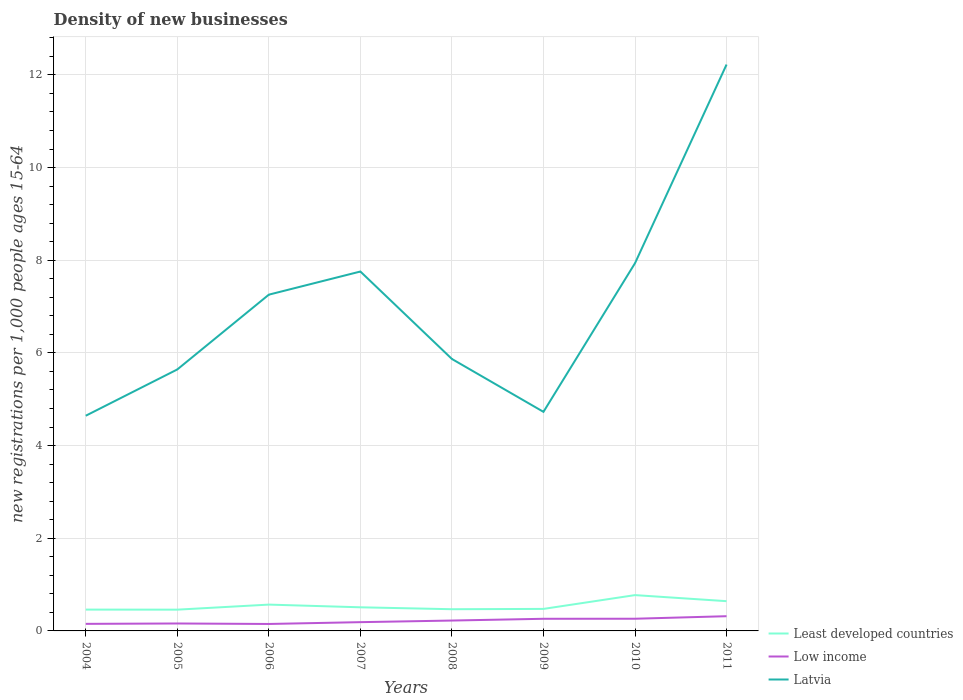Is the number of lines equal to the number of legend labels?
Your response must be concise. Yes. Across all years, what is the maximum number of new registrations in Latvia?
Ensure brevity in your answer.  4.64. What is the total number of new registrations in Least developed countries in the graph?
Provide a succinct answer. -0.11. What is the difference between the highest and the second highest number of new registrations in Latvia?
Ensure brevity in your answer.  7.58. What is the difference between the highest and the lowest number of new registrations in Low income?
Your answer should be very brief. 4. Is the number of new registrations in Least developed countries strictly greater than the number of new registrations in Low income over the years?
Your response must be concise. No. Does the graph contain grids?
Keep it short and to the point. Yes. What is the title of the graph?
Provide a short and direct response. Density of new businesses. Does "Sweden" appear as one of the legend labels in the graph?
Provide a succinct answer. No. What is the label or title of the X-axis?
Make the answer very short. Years. What is the label or title of the Y-axis?
Provide a succinct answer. New registrations per 1,0 people ages 15-64. What is the new registrations per 1,000 people ages 15-64 of Least developed countries in 2004?
Keep it short and to the point. 0.46. What is the new registrations per 1,000 people ages 15-64 in Low income in 2004?
Your answer should be compact. 0.15. What is the new registrations per 1,000 people ages 15-64 in Latvia in 2004?
Offer a terse response. 4.64. What is the new registrations per 1,000 people ages 15-64 of Least developed countries in 2005?
Your answer should be compact. 0.46. What is the new registrations per 1,000 people ages 15-64 in Low income in 2005?
Provide a succinct answer. 0.16. What is the new registrations per 1,000 people ages 15-64 in Latvia in 2005?
Ensure brevity in your answer.  5.64. What is the new registrations per 1,000 people ages 15-64 in Least developed countries in 2006?
Offer a very short reply. 0.57. What is the new registrations per 1,000 people ages 15-64 of Low income in 2006?
Give a very brief answer. 0.15. What is the new registrations per 1,000 people ages 15-64 of Latvia in 2006?
Provide a short and direct response. 7.26. What is the new registrations per 1,000 people ages 15-64 of Least developed countries in 2007?
Make the answer very short. 0.51. What is the new registrations per 1,000 people ages 15-64 of Low income in 2007?
Offer a terse response. 0.19. What is the new registrations per 1,000 people ages 15-64 in Latvia in 2007?
Give a very brief answer. 7.76. What is the new registrations per 1,000 people ages 15-64 of Least developed countries in 2008?
Give a very brief answer. 0.47. What is the new registrations per 1,000 people ages 15-64 in Low income in 2008?
Provide a succinct answer. 0.22. What is the new registrations per 1,000 people ages 15-64 of Latvia in 2008?
Provide a succinct answer. 5.87. What is the new registrations per 1,000 people ages 15-64 in Least developed countries in 2009?
Keep it short and to the point. 0.48. What is the new registrations per 1,000 people ages 15-64 in Low income in 2009?
Keep it short and to the point. 0.26. What is the new registrations per 1,000 people ages 15-64 in Latvia in 2009?
Give a very brief answer. 4.73. What is the new registrations per 1,000 people ages 15-64 of Least developed countries in 2010?
Your response must be concise. 0.77. What is the new registrations per 1,000 people ages 15-64 of Low income in 2010?
Your answer should be very brief. 0.26. What is the new registrations per 1,000 people ages 15-64 of Latvia in 2010?
Provide a succinct answer. 7.94. What is the new registrations per 1,000 people ages 15-64 in Least developed countries in 2011?
Your response must be concise. 0.64. What is the new registrations per 1,000 people ages 15-64 of Low income in 2011?
Give a very brief answer. 0.32. What is the new registrations per 1,000 people ages 15-64 of Latvia in 2011?
Keep it short and to the point. 12.22. Across all years, what is the maximum new registrations per 1,000 people ages 15-64 of Least developed countries?
Provide a succinct answer. 0.77. Across all years, what is the maximum new registrations per 1,000 people ages 15-64 in Low income?
Your answer should be very brief. 0.32. Across all years, what is the maximum new registrations per 1,000 people ages 15-64 in Latvia?
Provide a short and direct response. 12.22. Across all years, what is the minimum new registrations per 1,000 people ages 15-64 of Least developed countries?
Ensure brevity in your answer.  0.46. Across all years, what is the minimum new registrations per 1,000 people ages 15-64 in Low income?
Provide a short and direct response. 0.15. Across all years, what is the minimum new registrations per 1,000 people ages 15-64 in Latvia?
Your response must be concise. 4.64. What is the total new registrations per 1,000 people ages 15-64 of Least developed countries in the graph?
Your answer should be very brief. 4.36. What is the total new registrations per 1,000 people ages 15-64 in Low income in the graph?
Your response must be concise. 1.72. What is the total new registrations per 1,000 people ages 15-64 of Latvia in the graph?
Offer a terse response. 56.06. What is the difference between the new registrations per 1,000 people ages 15-64 of Least developed countries in 2004 and that in 2005?
Offer a terse response. 0. What is the difference between the new registrations per 1,000 people ages 15-64 in Low income in 2004 and that in 2005?
Your answer should be very brief. -0.01. What is the difference between the new registrations per 1,000 people ages 15-64 of Latvia in 2004 and that in 2005?
Give a very brief answer. -1. What is the difference between the new registrations per 1,000 people ages 15-64 of Least developed countries in 2004 and that in 2006?
Give a very brief answer. -0.11. What is the difference between the new registrations per 1,000 people ages 15-64 of Low income in 2004 and that in 2006?
Your answer should be very brief. 0. What is the difference between the new registrations per 1,000 people ages 15-64 in Latvia in 2004 and that in 2006?
Your answer should be compact. -2.61. What is the difference between the new registrations per 1,000 people ages 15-64 of Least developed countries in 2004 and that in 2007?
Your response must be concise. -0.05. What is the difference between the new registrations per 1,000 people ages 15-64 of Low income in 2004 and that in 2007?
Provide a short and direct response. -0.04. What is the difference between the new registrations per 1,000 people ages 15-64 in Latvia in 2004 and that in 2007?
Your answer should be very brief. -3.11. What is the difference between the new registrations per 1,000 people ages 15-64 in Least developed countries in 2004 and that in 2008?
Your answer should be compact. -0.01. What is the difference between the new registrations per 1,000 people ages 15-64 in Low income in 2004 and that in 2008?
Offer a very short reply. -0.07. What is the difference between the new registrations per 1,000 people ages 15-64 of Latvia in 2004 and that in 2008?
Offer a terse response. -1.23. What is the difference between the new registrations per 1,000 people ages 15-64 in Least developed countries in 2004 and that in 2009?
Give a very brief answer. -0.01. What is the difference between the new registrations per 1,000 people ages 15-64 in Low income in 2004 and that in 2009?
Ensure brevity in your answer.  -0.11. What is the difference between the new registrations per 1,000 people ages 15-64 of Latvia in 2004 and that in 2009?
Offer a terse response. -0.08. What is the difference between the new registrations per 1,000 people ages 15-64 of Least developed countries in 2004 and that in 2010?
Your answer should be compact. -0.31. What is the difference between the new registrations per 1,000 people ages 15-64 of Low income in 2004 and that in 2010?
Provide a succinct answer. -0.11. What is the difference between the new registrations per 1,000 people ages 15-64 in Latvia in 2004 and that in 2010?
Offer a very short reply. -3.29. What is the difference between the new registrations per 1,000 people ages 15-64 of Least developed countries in 2004 and that in 2011?
Your response must be concise. -0.18. What is the difference between the new registrations per 1,000 people ages 15-64 in Low income in 2004 and that in 2011?
Make the answer very short. -0.17. What is the difference between the new registrations per 1,000 people ages 15-64 of Latvia in 2004 and that in 2011?
Offer a terse response. -7.58. What is the difference between the new registrations per 1,000 people ages 15-64 of Least developed countries in 2005 and that in 2006?
Keep it short and to the point. -0.11. What is the difference between the new registrations per 1,000 people ages 15-64 in Low income in 2005 and that in 2006?
Offer a very short reply. 0.01. What is the difference between the new registrations per 1,000 people ages 15-64 in Latvia in 2005 and that in 2006?
Provide a short and direct response. -1.61. What is the difference between the new registrations per 1,000 people ages 15-64 in Least developed countries in 2005 and that in 2007?
Your answer should be very brief. -0.05. What is the difference between the new registrations per 1,000 people ages 15-64 of Low income in 2005 and that in 2007?
Your answer should be compact. -0.03. What is the difference between the new registrations per 1,000 people ages 15-64 of Latvia in 2005 and that in 2007?
Offer a terse response. -2.11. What is the difference between the new registrations per 1,000 people ages 15-64 in Least developed countries in 2005 and that in 2008?
Offer a terse response. -0.01. What is the difference between the new registrations per 1,000 people ages 15-64 of Low income in 2005 and that in 2008?
Provide a succinct answer. -0.06. What is the difference between the new registrations per 1,000 people ages 15-64 of Latvia in 2005 and that in 2008?
Make the answer very short. -0.23. What is the difference between the new registrations per 1,000 people ages 15-64 of Least developed countries in 2005 and that in 2009?
Ensure brevity in your answer.  -0.02. What is the difference between the new registrations per 1,000 people ages 15-64 in Low income in 2005 and that in 2009?
Ensure brevity in your answer.  -0.1. What is the difference between the new registrations per 1,000 people ages 15-64 of Latvia in 2005 and that in 2009?
Offer a very short reply. 0.92. What is the difference between the new registrations per 1,000 people ages 15-64 of Least developed countries in 2005 and that in 2010?
Provide a succinct answer. -0.31. What is the difference between the new registrations per 1,000 people ages 15-64 in Low income in 2005 and that in 2010?
Your answer should be compact. -0.1. What is the difference between the new registrations per 1,000 people ages 15-64 in Latvia in 2005 and that in 2010?
Provide a succinct answer. -2.29. What is the difference between the new registrations per 1,000 people ages 15-64 of Least developed countries in 2005 and that in 2011?
Provide a short and direct response. -0.18. What is the difference between the new registrations per 1,000 people ages 15-64 of Low income in 2005 and that in 2011?
Your response must be concise. -0.16. What is the difference between the new registrations per 1,000 people ages 15-64 of Latvia in 2005 and that in 2011?
Provide a short and direct response. -6.58. What is the difference between the new registrations per 1,000 people ages 15-64 in Least developed countries in 2006 and that in 2007?
Provide a short and direct response. 0.06. What is the difference between the new registrations per 1,000 people ages 15-64 of Low income in 2006 and that in 2007?
Provide a short and direct response. -0.04. What is the difference between the new registrations per 1,000 people ages 15-64 of Latvia in 2006 and that in 2007?
Offer a terse response. -0.5. What is the difference between the new registrations per 1,000 people ages 15-64 in Least developed countries in 2006 and that in 2008?
Offer a very short reply. 0.1. What is the difference between the new registrations per 1,000 people ages 15-64 in Low income in 2006 and that in 2008?
Ensure brevity in your answer.  -0.07. What is the difference between the new registrations per 1,000 people ages 15-64 in Latvia in 2006 and that in 2008?
Your response must be concise. 1.39. What is the difference between the new registrations per 1,000 people ages 15-64 of Least developed countries in 2006 and that in 2009?
Offer a terse response. 0.09. What is the difference between the new registrations per 1,000 people ages 15-64 of Low income in 2006 and that in 2009?
Your response must be concise. -0.11. What is the difference between the new registrations per 1,000 people ages 15-64 in Latvia in 2006 and that in 2009?
Give a very brief answer. 2.53. What is the difference between the new registrations per 1,000 people ages 15-64 of Least developed countries in 2006 and that in 2010?
Ensure brevity in your answer.  -0.2. What is the difference between the new registrations per 1,000 people ages 15-64 of Low income in 2006 and that in 2010?
Provide a short and direct response. -0.11. What is the difference between the new registrations per 1,000 people ages 15-64 of Latvia in 2006 and that in 2010?
Offer a very short reply. -0.68. What is the difference between the new registrations per 1,000 people ages 15-64 in Least developed countries in 2006 and that in 2011?
Provide a succinct answer. -0.07. What is the difference between the new registrations per 1,000 people ages 15-64 of Low income in 2006 and that in 2011?
Provide a short and direct response. -0.17. What is the difference between the new registrations per 1,000 people ages 15-64 of Latvia in 2006 and that in 2011?
Provide a succinct answer. -4.97. What is the difference between the new registrations per 1,000 people ages 15-64 of Least developed countries in 2007 and that in 2008?
Your answer should be compact. 0.04. What is the difference between the new registrations per 1,000 people ages 15-64 of Low income in 2007 and that in 2008?
Your answer should be compact. -0.03. What is the difference between the new registrations per 1,000 people ages 15-64 of Latvia in 2007 and that in 2008?
Your answer should be very brief. 1.89. What is the difference between the new registrations per 1,000 people ages 15-64 of Least developed countries in 2007 and that in 2009?
Provide a short and direct response. 0.03. What is the difference between the new registrations per 1,000 people ages 15-64 in Low income in 2007 and that in 2009?
Give a very brief answer. -0.07. What is the difference between the new registrations per 1,000 people ages 15-64 in Latvia in 2007 and that in 2009?
Ensure brevity in your answer.  3.03. What is the difference between the new registrations per 1,000 people ages 15-64 of Least developed countries in 2007 and that in 2010?
Provide a succinct answer. -0.26. What is the difference between the new registrations per 1,000 people ages 15-64 of Low income in 2007 and that in 2010?
Your answer should be very brief. -0.07. What is the difference between the new registrations per 1,000 people ages 15-64 of Latvia in 2007 and that in 2010?
Your response must be concise. -0.18. What is the difference between the new registrations per 1,000 people ages 15-64 in Least developed countries in 2007 and that in 2011?
Offer a terse response. -0.13. What is the difference between the new registrations per 1,000 people ages 15-64 of Low income in 2007 and that in 2011?
Keep it short and to the point. -0.13. What is the difference between the new registrations per 1,000 people ages 15-64 of Latvia in 2007 and that in 2011?
Your answer should be very brief. -4.47. What is the difference between the new registrations per 1,000 people ages 15-64 of Least developed countries in 2008 and that in 2009?
Keep it short and to the point. -0.01. What is the difference between the new registrations per 1,000 people ages 15-64 of Low income in 2008 and that in 2009?
Your answer should be very brief. -0.04. What is the difference between the new registrations per 1,000 people ages 15-64 in Latvia in 2008 and that in 2009?
Your response must be concise. 1.14. What is the difference between the new registrations per 1,000 people ages 15-64 in Least developed countries in 2008 and that in 2010?
Offer a terse response. -0.3. What is the difference between the new registrations per 1,000 people ages 15-64 of Low income in 2008 and that in 2010?
Your answer should be compact. -0.04. What is the difference between the new registrations per 1,000 people ages 15-64 in Latvia in 2008 and that in 2010?
Offer a terse response. -2.07. What is the difference between the new registrations per 1,000 people ages 15-64 in Least developed countries in 2008 and that in 2011?
Provide a succinct answer. -0.17. What is the difference between the new registrations per 1,000 people ages 15-64 in Low income in 2008 and that in 2011?
Make the answer very short. -0.09. What is the difference between the new registrations per 1,000 people ages 15-64 of Latvia in 2008 and that in 2011?
Your answer should be compact. -6.35. What is the difference between the new registrations per 1,000 people ages 15-64 in Least developed countries in 2009 and that in 2010?
Your answer should be compact. -0.3. What is the difference between the new registrations per 1,000 people ages 15-64 in Low income in 2009 and that in 2010?
Your answer should be compact. -0. What is the difference between the new registrations per 1,000 people ages 15-64 in Latvia in 2009 and that in 2010?
Keep it short and to the point. -3.21. What is the difference between the new registrations per 1,000 people ages 15-64 of Least developed countries in 2009 and that in 2011?
Your answer should be very brief. -0.17. What is the difference between the new registrations per 1,000 people ages 15-64 in Low income in 2009 and that in 2011?
Offer a very short reply. -0.06. What is the difference between the new registrations per 1,000 people ages 15-64 of Latvia in 2009 and that in 2011?
Offer a terse response. -7.5. What is the difference between the new registrations per 1,000 people ages 15-64 in Least developed countries in 2010 and that in 2011?
Ensure brevity in your answer.  0.13. What is the difference between the new registrations per 1,000 people ages 15-64 in Low income in 2010 and that in 2011?
Provide a short and direct response. -0.05. What is the difference between the new registrations per 1,000 people ages 15-64 of Latvia in 2010 and that in 2011?
Offer a very short reply. -4.29. What is the difference between the new registrations per 1,000 people ages 15-64 of Least developed countries in 2004 and the new registrations per 1,000 people ages 15-64 of Low income in 2005?
Your answer should be compact. 0.3. What is the difference between the new registrations per 1,000 people ages 15-64 in Least developed countries in 2004 and the new registrations per 1,000 people ages 15-64 in Latvia in 2005?
Provide a short and direct response. -5.18. What is the difference between the new registrations per 1,000 people ages 15-64 of Low income in 2004 and the new registrations per 1,000 people ages 15-64 of Latvia in 2005?
Ensure brevity in your answer.  -5.49. What is the difference between the new registrations per 1,000 people ages 15-64 of Least developed countries in 2004 and the new registrations per 1,000 people ages 15-64 of Low income in 2006?
Make the answer very short. 0.31. What is the difference between the new registrations per 1,000 people ages 15-64 in Least developed countries in 2004 and the new registrations per 1,000 people ages 15-64 in Latvia in 2006?
Your answer should be compact. -6.8. What is the difference between the new registrations per 1,000 people ages 15-64 in Low income in 2004 and the new registrations per 1,000 people ages 15-64 in Latvia in 2006?
Your answer should be very brief. -7.11. What is the difference between the new registrations per 1,000 people ages 15-64 of Least developed countries in 2004 and the new registrations per 1,000 people ages 15-64 of Low income in 2007?
Offer a very short reply. 0.27. What is the difference between the new registrations per 1,000 people ages 15-64 in Least developed countries in 2004 and the new registrations per 1,000 people ages 15-64 in Latvia in 2007?
Offer a very short reply. -7.3. What is the difference between the new registrations per 1,000 people ages 15-64 of Low income in 2004 and the new registrations per 1,000 people ages 15-64 of Latvia in 2007?
Make the answer very short. -7.6. What is the difference between the new registrations per 1,000 people ages 15-64 in Least developed countries in 2004 and the new registrations per 1,000 people ages 15-64 in Low income in 2008?
Provide a short and direct response. 0.24. What is the difference between the new registrations per 1,000 people ages 15-64 of Least developed countries in 2004 and the new registrations per 1,000 people ages 15-64 of Latvia in 2008?
Make the answer very short. -5.41. What is the difference between the new registrations per 1,000 people ages 15-64 of Low income in 2004 and the new registrations per 1,000 people ages 15-64 of Latvia in 2008?
Make the answer very short. -5.72. What is the difference between the new registrations per 1,000 people ages 15-64 in Least developed countries in 2004 and the new registrations per 1,000 people ages 15-64 in Low income in 2009?
Offer a very short reply. 0.2. What is the difference between the new registrations per 1,000 people ages 15-64 in Least developed countries in 2004 and the new registrations per 1,000 people ages 15-64 in Latvia in 2009?
Your answer should be very brief. -4.27. What is the difference between the new registrations per 1,000 people ages 15-64 in Low income in 2004 and the new registrations per 1,000 people ages 15-64 in Latvia in 2009?
Ensure brevity in your answer.  -4.58. What is the difference between the new registrations per 1,000 people ages 15-64 of Least developed countries in 2004 and the new registrations per 1,000 people ages 15-64 of Low income in 2010?
Keep it short and to the point. 0.2. What is the difference between the new registrations per 1,000 people ages 15-64 of Least developed countries in 2004 and the new registrations per 1,000 people ages 15-64 of Latvia in 2010?
Provide a succinct answer. -7.48. What is the difference between the new registrations per 1,000 people ages 15-64 in Low income in 2004 and the new registrations per 1,000 people ages 15-64 in Latvia in 2010?
Your response must be concise. -7.78. What is the difference between the new registrations per 1,000 people ages 15-64 of Least developed countries in 2004 and the new registrations per 1,000 people ages 15-64 of Low income in 2011?
Offer a very short reply. 0.14. What is the difference between the new registrations per 1,000 people ages 15-64 of Least developed countries in 2004 and the new registrations per 1,000 people ages 15-64 of Latvia in 2011?
Ensure brevity in your answer.  -11.76. What is the difference between the new registrations per 1,000 people ages 15-64 in Low income in 2004 and the new registrations per 1,000 people ages 15-64 in Latvia in 2011?
Provide a succinct answer. -12.07. What is the difference between the new registrations per 1,000 people ages 15-64 in Least developed countries in 2005 and the new registrations per 1,000 people ages 15-64 in Low income in 2006?
Ensure brevity in your answer.  0.31. What is the difference between the new registrations per 1,000 people ages 15-64 of Least developed countries in 2005 and the new registrations per 1,000 people ages 15-64 of Latvia in 2006?
Your answer should be very brief. -6.8. What is the difference between the new registrations per 1,000 people ages 15-64 in Low income in 2005 and the new registrations per 1,000 people ages 15-64 in Latvia in 2006?
Offer a very short reply. -7.1. What is the difference between the new registrations per 1,000 people ages 15-64 of Least developed countries in 2005 and the new registrations per 1,000 people ages 15-64 of Low income in 2007?
Ensure brevity in your answer.  0.27. What is the difference between the new registrations per 1,000 people ages 15-64 in Least developed countries in 2005 and the new registrations per 1,000 people ages 15-64 in Latvia in 2007?
Your answer should be very brief. -7.3. What is the difference between the new registrations per 1,000 people ages 15-64 in Low income in 2005 and the new registrations per 1,000 people ages 15-64 in Latvia in 2007?
Ensure brevity in your answer.  -7.6. What is the difference between the new registrations per 1,000 people ages 15-64 of Least developed countries in 2005 and the new registrations per 1,000 people ages 15-64 of Low income in 2008?
Provide a short and direct response. 0.23. What is the difference between the new registrations per 1,000 people ages 15-64 of Least developed countries in 2005 and the new registrations per 1,000 people ages 15-64 of Latvia in 2008?
Provide a succinct answer. -5.41. What is the difference between the new registrations per 1,000 people ages 15-64 in Low income in 2005 and the new registrations per 1,000 people ages 15-64 in Latvia in 2008?
Provide a succinct answer. -5.71. What is the difference between the new registrations per 1,000 people ages 15-64 in Least developed countries in 2005 and the new registrations per 1,000 people ages 15-64 in Low income in 2009?
Ensure brevity in your answer.  0.2. What is the difference between the new registrations per 1,000 people ages 15-64 in Least developed countries in 2005 and the new registrations per 1,000 people ages 15-64 in Latvia in 2009?
Keep it short and to the point. -4.27. What is the difference between the new registrations per 1,000 people ages 15-64 in Low income in 2005 and the new registrations per 1,000 people ages 15-64 in Latvia in 2009?
Your response must be concise. -4.57. What is the difference between the new registrations per 1,000 people ages 15-64 of Least developed countries in 2005 and the new registrations per 1,000 people ages 15-64 of Low income in 2010?
Offer a very short reply. 0.2. What is the difference between the new registrations per 1,000 people ages 15-64 of Least developed countries in 2005 and the new registrations per 1,000 people ages 15-64 of Latvia in 2010?
Keep it short and to the point. -7.48. What is the difference between the new registrations per 1,000 people ages 15-64 in Low income in 2005 and the new registrations per 1,000 people ages 15-64 in Latvia in 2010?
Keep it short and to the point. -7.78. What is the difference between the new registrations per 1,000 people ages 15-64 of Least developed countries in 2005 and the new registrations per 1,000 people ages 15-64 of Low income in 2011?
Offer a very short reply. 0.14. What is the difference between the new registrations per 1,000 people ages 15-64 in Least developed countries in 2005 and the new registrations per 1,000 people ages 15-64 in Latvia in 2011?
Your response must be concise. -11.77. What is the difference between the new registrations per 1,000 people ages 15-64 of Low income in 2005 and the new registrations per 1,000 people ages 15-64 of Latvia in 2011?
Offer a very short reply. -12.06. What is the difference between the new registrations per 1,000 people ages 15-64 of Least developed countries in 2006 and the new registrations per 1,000 people ages 15-64 of Low income in 2007?
Keep it short and to the point. 0.38. What is the difference between the new registrations per 1,000 people ages 15-64 in Least developed countries in 2006 and the new registrations per 1,000 people ages 15-64 in Latvia in 2007?
Make the answer very short. -7.19. What is the difference between the new registrations per 1,000 people ages 15-64 in Low income in 2006 and the new registrations per 1,000 people ages 15-64 in Latvia in 2007?
Your answer should be very brief. -7.61. What is the difference between the new registrations per 1,000 people ages 15-64 of Least developed countries in 2006 and the new registrations per 1,000 people ages 15-64 of Low income in 2008?
Your response must be concise. 0.34. What is the difference between the new registrations per 1,000 people ages 15-64 in Least developed countries in 2006 and the new registrations per 1,000 people ages 15-64 in Latvia in 2008?
Offer a very short reply. -5.3. What is the difference between the new registrations per 1,000 people ages 15-64 in Low income in 2006 and the new registrations per 1,000 people ages 15-64 in Latvia in 2008?
Provide a short and direct response. -5.72. What is the difference between the new registrations per 1,000 people ages 15-64 in Least developed countries in 2006 and the new registrations per 1,000 people ages 15-64 in Low income in 2009?
Offer a very short reply. 0.31. What is the difference between the new registrations per 1,000 people ages 15-64 in Least developed countries in 2006 and the new registrations per 1,000 people ages 15-64 in Latvia in 2009?
Offer a terse response. -4.16. What is the difference between the new registrations per 1,000 people ages 15-64 of Low income in 2006 and the new registrations per 1,000 people ages 15-64 of Latvia in 2009?
Offer a terse response. -4.58. What is the difference between the new registrations per 1,000 people ages 15-64 of Least developed countries in 2006 and the new registrations per 1,000 people ages 15-64 of Low income in 2010?
Give a very brief answer. 0.31. What is the difference between the new registrations per 1,000 people ages 15-64 in Least developed countries in 2006 and the new registrations per 1,000 people ages 15-64 in Latvia in 2010?
Give a very brief answer. -7.37. What is the difference between the new registrations per 1,000 people ages 15-64 in Low income in 2006 and the new registrations per 1,000 people ages 15-64 in Latvia in 2010?
Provide a short and direct response. -7.79. What is the difference between the new registrations per 1,000 people ages 15-64 in Least developed countries in 2006 and the new registrations per 1,000 people ages 15-64 in Low income in 2011?
Ensure brevity in your answer.  0.25. What is the difference between the new registrations per 1,000 people ages 15-64 of Least developed countries in 2006 and the new registrations per 1,000 people ages 15-64 of Latvia in 2011?
Keep it short and to the point. -11.66. What is the difference between the new registrations per 1,000 people ages 15-64 of Low income in 2006 and the new registrations per 1,000 people ages 15-64 of Latvia in 2011?
Ensure brevity in your answer.  -12.07. What is the difference between the new registrations per 1,000 people ages 15-64 of Least developed countries in 2007 and the new registrations per 1,000 people ages 15-64 of Low income in 2008?
Your answer should be very brief. 0.29. What is the difference between the new registrations per 1,000 people ages 15-64 in Least developed countries in 2007 and the new registrations per 1,000 people ages 15-64 in Latvia in 2008?
Ensure brevity in your answer.  -5.36. What is the difference between the new registrations per 1,000 people ages 15-64 in Low income in 2007 and the new registrations per 1,000 people ages 15-64 in Latvia in 2008?
Your answer should be very brief. -5.68. What is the difference between the new registrations per 1,000 people ages 15-64 of Least developed countries in 2007 and the new registrations per 1,000 people ages 15-64 of Low income in 2009?
Offer a terse response. 0.25. What is the difference between the new registrations per 1,000 people ages 15-64 in Least developed countries in 2007 and the new registrations per 1,000 people ages 15-64 in Latvia in 2009?
Offer a very short reply. -4.22. What is the difference between the new registrations per 1,000 people ages 15-64 in Low income in 2007 and the new registrations per 1,000 people ages 15-64 in Latvia in 2009?
Give a very brief answer. -4.54. What is the difference between the new registrations per 1,000 people ages 15-64 of Least developed countries in 2007 and the new registrations per 1,000 people ages 15-64 of Low income in 2010?
Your answer should be compact. 0.25. What is the difference between the new registrations per 1,000 people ages 15-64 in Least developed countries in 2007 and the new registrations per 1,000 people ages 15-64 in Latvia in 2010?
Provide a short and direct response. -7.43. What is the difference between the new registrations per 1,000 people ages 15-64 in Low income in 2007 and the new registrations per 1,000 people ages 15-64 in Latvia in 2010?
Your answer should be very brief. -7.75. What is the difference between the new registrations per 1,000 people ages 15-64 in Least developed countries in 2007 and the new registrations per 1,000 people ages 15-64 in Low income in 2011?
Your response must be concise. 0.19. What is the difference between the new registrations per 1,000 people ages 15-64 in Least developed countries in 2007 and the new registrations per 1,000 people ages 15-64 in Latvia in 2011?
Provide a succinct answer. -11.71. What is the difference between the new registrations per 1,000 people ages 15-64 in Low income in 2007 and the new registrations per 1,000 people ages 15-64 in Latvia in 2011?
Offer a very short reply. -12.03. What is the difference between the new registrations per 1,000 people ages 15-64 of Least developed countries in 2008 and the new registrations per 1,000 people ages 15-64 of Low income in 2009?
Offer a very short reply. 0.21. What is the difference between the new registrations per 1,000 people ages 15-64 in Least developed countries in 2008 and the new registrations per 1,000 people ages 15-64 in Latvia in 2009?
Provide a succinct answer. -4.26. What is the difference between the new registrations per 1,000 people ages 15-64 in Low income in 2008 and the new registrations per 1,000 people ages 15-64 in Latvia in 2009?
Ensure brevity in your answer.  -4.5. What is the difference between the new registrations per 1,000 people ages 15-64 of Least developed countries in 2008 and the new registrations per 1,000 people ages 15-64 of Low income in 2010?
Make the answer very short. 0.21. What is the difference between the new registrations per 1,000 people ages 15-64 in Least developed countries in 2008 and the new registrations per 1,000 people ages 15-64 in Latvia in 2010?
Provide a succinct answer. -7.47. What is the difference between the new registrations per 1,000 people ages 15-64 in Low income in 2008 and the new registrations per 1,000 people ages 15-64 in Latvia in 2010?
Offer a terse response. -7.71. What is the difference between the new registrations per 1,000 people ages 15-64 of Least developed countries in 2008 and the new registrations per 1,000 people ages 15-64 of Low income in 2011?
Provide a short and direct response. 0.15. What is the difference between the new registrations per 1,000 people ages 15-64 in Least developed countries in 2008 and the new registrations per 1,000 people ages 15-64 in Latvia in 2011?
Your answer should be compact. -11.76. What is the difference between the new registrations per 1,000 people ages 15-64 in Low income in 2008 and the new registrations per 1,000 people ages 15-64 in Latvia in 2011?
Offer a terse response. -12. What is the difference between the new registrations per 1,000 people ages 15-64 in Least developed countries in 2009 and the new registrations per 1,000 people ages 15-64 in Low income in 2010?
Your response must be concise. 0.21. What is the difference between the new registrations per 1,000 people ages 15-64 in Least developed countries in 2009 and the new registrations per 1,000 people ages 15-64 in Latvia in 2010?
Offer a very short reply. -7.46. What is the difference between the new registrations per 1,000 people ages 15-64 in Low income in 2009 and the new registrations per 1,000 people ages 15-64 in Latvia in 2010?
Offer a terse response. -7.67. What is the difference between the new registrations per 1,000 people ages 15-64 in Least developed countries in 2009 and the new registrations per 1,000 people ages 15-64 in Low income in 2011?
Give a very brief answer. 0.16. What is the difference between the new registrations per 1,000 people ages 15-64 in Least developed countries in 2009 and the new registrations per 1,000 people ages 15-64 in Latvia in 2011?
Offer a terse response. -11.75. What is the difference between the new registrations per 1,000 people ages 15-64 of Low income in 2009 and the new registrations per 1,000 people ages 15-64 of Latvia in 2011?
Give a very brief answer. -11.96. What is the difference between the new registrations per 1,000 people ages 15-64 in Least developed countries in 2010 and the new registrations per 1,000 people ages 15-64 in Low income in 2011?
Keep it short and to the point. 0.46. What is the difference between the new registrations per 1,000 people ages 15-64 in Least developed countries in 2010 and the new registrations per 1,000 people ages 15-64 in Latvia in 2011?
Make the answer very short. -11.45. What is the difference between the new registrations per 1,000 people ages 15-64 in Low income in 2010 and the new registrations per 1,000 people ages 15-64 in Latvia in 2011?
Give a very brief answer. -11.96. What is the average new registrations per 1,000 people ages 15-64 of Least developed countries per year?
Offer a terse response. 0.54. What is the average new registrations per 1,000 people ages 15-64 in Low income per year?
Your answer should be compact. 0.21. What is the average new registrations per 1,000 people ages 15-64 in Latvia per year?
Your answer should be very brief. 7.01. In the year 2004, what is the difference between the new registrations per 1,000 people ages 15-64 in Least developed countries and new registrations per 1,000 people ages 15-64 in Low income?
Give a very brief answer. 0.31. In the year 2004, what is the difference between the new registrations per 1,000 people ages 15-64 in Least developed countries and new registrations per 1,000 people ages 15-64 in Latvia?
Give a very brief answer. -4.18. In the year 2004, what is the difference between the new registrations per 1,000 people ages 15-64 of Low income and new registrations per 1,000 people ages 15-64 of Latvia?
Offer a terse response. -4.49. In the year 2005, what is the difference between the new registrations per 1,000 people ages 15-64 of Least developed countries and new registrations per 1,000 people ages 15-64 of Low income?
Offer a terse response. 0.3. In the year 2005, what is the difference between the new registrations per 1,000 people ages 15-64 of Least developed countries and new registrations per 1,000 people ages 15-64 of Latvia?
Give a very brief answer. -5.18. In the year 2005, what is the difference between the new registrations per 1,000 people ages 15-64 in Low income and new registrations per 1,000 people ages 15-64 in Latvia?
Your response must be concise. -5.48. In the year 2006, what is the difference between the new registrations per 1,000 people ages 15-64 in Least developed countries and new registrations per 1,000 people ages 15-64 in Low income?
Make the answer very short. 0.42. In the year 2006, what is the difference between the new registrations per 1,000 people ages 15-64 in Least developed countries and new registrations per 1,000 people ages 15-64 in Latvia?
Your answer should be compact. -6.69. In the year 2006, what is the difference between the new registrations per 1,000 people ages 15-64 in Low income and new registrations per 1,000 people ages 15-64 in Latvia?
Offer a very short reply. -7.11. In the year 2007, what is the difference between the new registrations per 1,000 people ages 15-64 in Least developed countries and new registrations per 1,000 people ages 15-64 in Low income?
Offer a very short reply. 0.32. In the year 2007, what is the difference between the new registrations per 1,000 people ages 15-64 of Least developed countries and new registrations per 1,000 people ages 15-64 of Latvia?
Your response must be concise. -7.25. In the year 2007, what is the difference between the new registrations per 1,000 people ages 15-64 in Low income and new registrations per 1,000 people ages 15-64 in Latvia?
Offer a terse response. -7.57. In the year 2008, what is the difference between the new registrations per 1,000 people ages 15-64 in Least developed countries and new registrations per 1,000 people ages 15-64 in Low income?
Keep it short and to the point. 0.24. In the year 2008, what is the difference between the new registrations per 1,000 people ages 15-64 in Least developed countries and new registrations per 1,000 people ages 15-64 in Latvia?
Offer a terse response. -5.4. In the year 2008, what is the difference between the new registrations per 1,000 people ages 15-64 of Low income and new registrations per 1,000 people ages 15-64 of Latvia?
Keep it short and to the point. -5.65. In the year 2009, what is the difference between the new registrations per 1,000 people ages 15-64 of Least developed countries and new registrations per 1,000 people ages 15-64 of Low income?
Offer a terse response. 0.21. In the year 2009, what is the difference between the new registrations per 1,000 people ages 15-64 of Least developed countries and new registrations per 1,000 people ages 15-64 of Latvia?
Your answer should be compact. -4.25. In the year 2009, what is the difference between the new registrations per 1,000 people ages 15-64 of Low income and new registrations per 1,000 people ages 15-64 of Latvia?
Provide a succinct answer. -4.47. In the year 2010, what is the difference between the new registrations per 1,000 people ages 15-64 of Least developed countries and new registrations per 1,000 people ages 15-64 of Low income?
Your answer should be compact. 0.51. In the year 2010, what is the difference between the new registrations per 1,000 people ages 15-64 in Least developed countries and new registrations per 1,000 people ages 15-64 in Latvia?
Offer a very short reply. -7.16. In the year 2010, what is the difference between the new registrations per 1,000 people ages 15-64 of Low income and new registrations per 1,000 people ages 15-64 of Latvia?
Keep it short and to the point. -7.67. In the year 2011, what is the difference between the new registrations per 1,000 people ages 15-64 of Least developed countries and new registrations per 1,000 people ages 15-64 of Low income?
Make the answer very short. 0.32. In the year 2011, what is the difference between the new registrations per 1,000 people ages 15-64 of Least developed countries and new registrations per 1,000 people ages 15-64 of Latvia?
Offer a terse response. -11.58. In the year 2011, what is the difference between the new registrations per 1,000 people ages 15-64 of Low income and new registrations per 1,000 people ages 15-64 of Latvia?
Offer a very short reply. -11.91. What is the ratio of the new registrations per 1,000 people ages 15-64 in Least developed countries in 2004 to that in 2005?
Ensure brevity in your answer.  1. What is the ratio of the new registrations per 1,000 people ages 15-64 of Low income in 2004 to that in 2005?
Make the answer very short. 0.95. What is the ratio of the new registrations per 1,000 people ages 15-64 in Latvia in 2004 to that in 2005?
Your answer should be very brief. 0.82. What is the ratio of the new registrations per 1,000 people ages 15-64 of Least developed countries in 2004 to that in 2006?
Offer a very short reply. 0.81. What is the ratio of the new registrations per 1,000 people ages 15-64 of Low income in 2004 to that in 2006?
Your response must be concise. 1.01. What is the ratio of the new registrations per 1,000 people ages 15-64 in Latvia in 2004 to that in 2006?
Ensure brevity in your answer.  0.64. What is the ratio of the new registrations per 1,000 people ages 15-64 of Least developed countries in 2004 to that in 2007?
Ensure brevity in your answer.  0.9. What is the ratio of the new registrations per 1,000 people ages 15-64 in Low income in 2004 to that in 2007?
Give a very brief answer. 0.81. What is the ratio of the new registrations per 1,000 people ages 15-64 in Latvia in 2004 to that in 2007?
Provide a succinct answer. 0.6. What is the ratio of the new registrations per 1,000 people ages 15-64 of Least developed countries in 2004 to that in 2008?
Offer a terse response. 0.98. What is the ratio of the new registrations per 1,000 people ages 15-64 of Low income in 2004 to that in 2008?
Ensure brevity in your answer.  0.68. What is the ratio of the new registrations per 1,000 people ages 15-64 of Latvia in 2004 to that in 2008?
Your answer should be compact. 0.79. What is the ratio of the new registrations per 1,000 people ages 15-64 in Least developed countries in 2004 to that in 2009?
Make the answer very short. 0.97. What is the ratio of the new registrations per 1,000 people ages 15-64 of Low income in 2004 to that in 2009?
Your answer should be compact. 0.58. What is the ratio of the new registrations per 1,000 people ages 15-64 in Latvia in 2004 to that in 2009?
Keep it short and to the point. 0.98. What is the ratio of the new registrations per 1,000 people ages 15-64 of Least developed countries in 2004 to that in 2010?
Offer a terse response. 0.6. What is the ratio of the new registrations per 1,000 people ages 15-64 of Low income in 2004 to that in 2010?
Your answer should be compact. 0.58. What is the ratio of the new registrations per 1,000 people ages 15-64 in Latvia in 2004 to that in 2010?
Offer a very short reply. 0.59. What is the ratio of the new registrations per 1,000 people ages 15-64 in Least developed countries in 2004 to that in 2011?
Keep it short and to the point. 0.72. What is the ratio of the new registrations per 1,000 people ages 15-64 of Low income in 2004 to that in 2011?
Your answer should be very brief. 0.48. What is the ratio of the new registrations per 1,000 people ages 15-64 of Latvia in 2004 to that in 2011?
Offer a terse response. 0.38. What is the ratio of the new registrations per 1,000 people ages 15-64 of Least developed countries in 2005 to that in 2006?
Your response must be concise. 0.81. What is the ratio of the new registrations per 1,000 people ages 15-64 in Low income in 2005 to that in 2006?
Your answer should be compact. 1.07. What is the ratio of the new registrations per 1,000 people ages 15-64 in Latvia in 2005 to that in 2006?
Make the answer very short. 0.78. What is the ratio of the new registrations per 1,000 people ages 15-64 in Least developed countries in 2005 to that in 2007?
Make the answer very short. 0.9. What is the ratio of the new registrations per 1,000 people ages 15-64 in Low income in 2005 to that in 2007?
Ensure brevity in your answer.  0.85. What is the ratio of the new registrations per 1,000 people ages 15-64 in Latvia in 2005 to that in 2007?
Keep it short and to the point. 0.73. What is the ratio of the new registrations per 1,000 people ages 15-64 of Least developed countries in 2005 to that in 2008?
Provide a short and direct response. 0.98. What is the ratio of the new registrations per 1,000 people ages 15-64 of Low income in 2005 to that in 2008?
Your response must be concise. 0.72. What is the ratio of the new registrations per 1,000 people ages 15-64 in Latvia in 2005 to that in 2008?
Make the answer very short. 0.96. What is the ratio of the new registrations per 1,000 people ages 15-64 of Least developed countries in 2005 to that in 2009?
Provide a short and direct response. 0.97. What is the ratio of the new registrations per 1,000 people ages 15-64 in Low income in 2005 to that in 2009?
Keep it short and to the point. 0.61. What is the ratio of the new registrations per 1,000 people ages 15-64 of Latvia in 2005 to that in 2009?
Your answer should be very brief. 1.19. What is the ratio of the new registrations per 1,000 people ages 15-64 in Least developed countries in 2005 to that in 2010?
Provide a succinct answer. 0.59. What is the ratio of the new registrations per 1,000 people ages 15-64 of Low income in 2005 to that in 2010?
Your answer should be very brief. 0.61. What is the ratio of the new registrations per 1,000 people ages 15-64 of Latvia in 2005 to that in 2010?
Your response must be concise. 0.71. What is the ratio of the new registrations per 1,000 people ages 15-64 in Least developed countries in 2005 to that in 2011?
Give a very brief answer. 0.71. What is the ratio of the new registrations per 1,000 people ages 15-64 in Low income in 2005 to that in 2011?
Your answer should be very brief. 0.51. What is the ratio of the new registrations per 1,000 people ages 15-64 of Latvia in 2005 to that in 2011?
Make the answer very short. 0.46. What is the ratio of the new registrations per 1,000 people ages 15-64 of Least developed countries in 2006 to that in 2007?
Keep it short and to the point. 1.11. What is the ratio of the new registrations per 1,000 people ages 15-64 in Low income in 2006 to that in 2007?
Keep it short and to the point. 0.79. What is the ratio of the new registrations per 1,000 people ages 15-64 of Latvia in 2006 to that in 2007?
Make the answer very short. 0.94. What is the ratio of the new registrations per 1,000 people ages 15-64 of Least developed countries in 2006 to that in 2008?
Provide a short and direct response. 1.21. What is the ratio of the new registrations per 1,000 people ages 15-64 of Low income in 2006 to that in 2008?
Your answer should be compact. 0.67. What is the ratio of the new registrations per 1,000 people ages 15-64 of Latvia in 2006 to that in 2008?
Offer a very short reply. 1.24. What is the ratio of the new registrations per 1,000 people ages 15-64 of Least developed countries in 2006 to that in 2009?
Give a very brief answer. 1.2. What is the ratio of the new registrations per 1,000 people ages 15-64 in Low income in 2006 to that in 2009?
Provide a short and direct response. 0.57. What is the ratio of the new registrations per 1,000 people ages 15-64 of Latvia in 2006 to that in 2009?
Provide a short and direct response. 1.53. What is the ratio of the new registrations per 1,000 people ages 15-64 in Least developed countries in 2006 to that in 2010?
Your answer should be compact. 0.73. What is the ratio of the new registrations per 1,000 people ages 15-64 in Low income in 2006 to that in 2010?
Your answer should be compact. 0.57. What is the ratio of the new registrations per 1,000 people ages 15-64 of Latvia in 2006 to that in 2010?
Your answer should be very brief. 0.91. What is the ratio of the new registrations per 1,000 people ages 15-64 of Least developed countries in 2006 to that in 2011?
Provide a short and direct response. 0.88. What is the ratio of the new registrations per 1,000 people ages 15-64 in Low income in 2006 to that in 2011?
Provide a short and direct response. 0.47. What is the ratio of the new registrations per 1,000 people ages 15-64 in Latvia in 2006 to that in 2011?
Offer a terse response. 0.59. What is the ratio of the new registrations per 1,000 people ages 15-64 in Least developed countries in 2007 to that in 2008?
Make the answer very short. 1.09. What is the ratio of the new registrations per 1,000 people ages 15-64 in Low income in 2007 to that in 2008?
Make the answer very short. 0.84. What is the ratio of the new registrations per 1,000 people ages 15-64 in Latvia in 2007 to that in 2008?
Keep it short and to the point. 1.32. What is the ratio of the new registrations per 1,000 people ages 15-64 in Least developed countries in 2007 to that in 2009?
Keep it short and to the point. 1.07. What is the ratio of the new registrations per 1,000 people ages 15-64 of Low income in 2007 to that in 2009?
Your response must be concise. 0.72. What is the ratio of the new registrations per 1,000 people ages 15-64 of Latvia in 2007 to that in 2009?
Provide a succinct answer. 1.64. What is the ratio of the new registrations per 1,000 people ages 15-64 in Least developed countries in 2007 to that in 2010?
Offer a very short reply. 0.66. What is the ratio of the new registrations per 1,000 people ages 15-64 in Low income in 2007 to that in 2010?
Make the answer very short. 0.72. What is the ratio of the new registrations per 1,000 people ages 15-64 in Latvia in 2007 to that in 2010?
Provide a short and direct response. 0.98. What is the ratio of the new registrations per 1,000 people ages 15-64 of Least developed countries in 2007 to that in 2011?
Your answer should be compact. 0.79. What is the ratio of the new registrations per 1,000 people ages 15-64 of Low income in 2007 to that in 2011?
Give a very brief answer. 0.6. What is the ratio of the new registrations per 1,000 people ages 15-64 of Latvia in 2007 to that in 2011?
Ensure brevity in your answer.  0.63. What is the ratio of the new registrations per 1,000 people ages 15-64 of Low income in 2008 to that in 2009?
Offer a very short reply. 0.85. What is the ratio of the new registrations per 1,000 people ages 15-64 in Latvia in 2008 to that in 2009?
Make the answer very short. 1.24. What is the ratio of the new registrations per 1,000 people ages 15-64 in Least developed countries in 2008 to that in 2010?
Give a very brief answer. 0.61. What is the ratio of the new registrations per 1,000 people ages 15-64 of Low income in 2008 to that in 2010?
Your answer should be very brief. 0.85. What is the ratio of the new registrations per 1,000 people ages 15-64 of Latvia in 2008 to that in 2010?
Your answer should be compact. 0.74. What is the ratio of the new registrations per 1,000 people ages 15-64 in Least developed countries in 2008 to that in 2011?
Offer a terse response. 0.73. What is the ratio of the new registrations per 1,000 people ages 15-64 of Low income in 2008 to that in 2011?
Give a very brief answer. 0.7. What is the ratio of the new registrations per 1,000 people ages 15-64 of Latvia in 2008 to that in 2011?
Make the answer very short. 0.48. What is the ratio of the new registrations per 1,000 people ages 15-64 in Least developed countries in 2009 to that in 2010?
Ensure brevity in your answer.  0.61. What is the ratio of the new registrations per 1,000 people ages 15-64 in Latvia in 2009 to that in 2010?
Your response must be concise. 0.6. What is the ratio of the new registrations per 1,000 people ages 15-64 of Least developed countries in 2009 to that in 2011?
Ensure brevity in your answer.  0.74. What is the ratio of the new registrations per 1,000 people ages 15-64 in Low income in 2009 to that in 2011?
Your answer should be very brief. 0.82. What is the ratio of the new registrations per 1,000 people ages 15-64 in Latvia in 2009 to that in 2011?
Offer a terse response. 0.39. What is the ratio of the new registrations per 1,000 people ages 15-64 in Least developed countries in 2010 to that in 2011?
Make the answer very short. 1.2. What is the ratio of the new registrations per 1,000 people ages 15-64 in Low income in 2010 to that in 2011?
Your answer should be very brief. 0.83. What is the ratio of the new registrations per 1,000 people ages 15-64 of Latvia in 2010 to that in 2011?
Keep it short and to the point. 0.65. What is the difference between the highest and the second highest new registrations per 1,000 people ages 15-64 in Least developed countries?
Provide a succinct answer. 0.13. What is the difference between the highest and the second highest new registrations per 1,000 people ages 15-64 of Low income?
Give a very brief answer. 0.05. What is the difference between the highest and the second highest new registrations per 1,000 people ages 15-64 in Latvia?
Offer a very short reply. 4.29. What is the difference between the highest and the lowest new registrations per 1,000 people ages 15-64 of Least developed countries?
Offer a very short reply. 0.31. What is the difference between the highest and the lowest new registrations per 1,000 people ages 15-64 in Low income?
Keep it short and to the point. 0.17. What is the difference between the highest and the lowest new registrations per 1,000 people ages 15-64 of Latvia?
Provide a short and direct response. 7.58. 